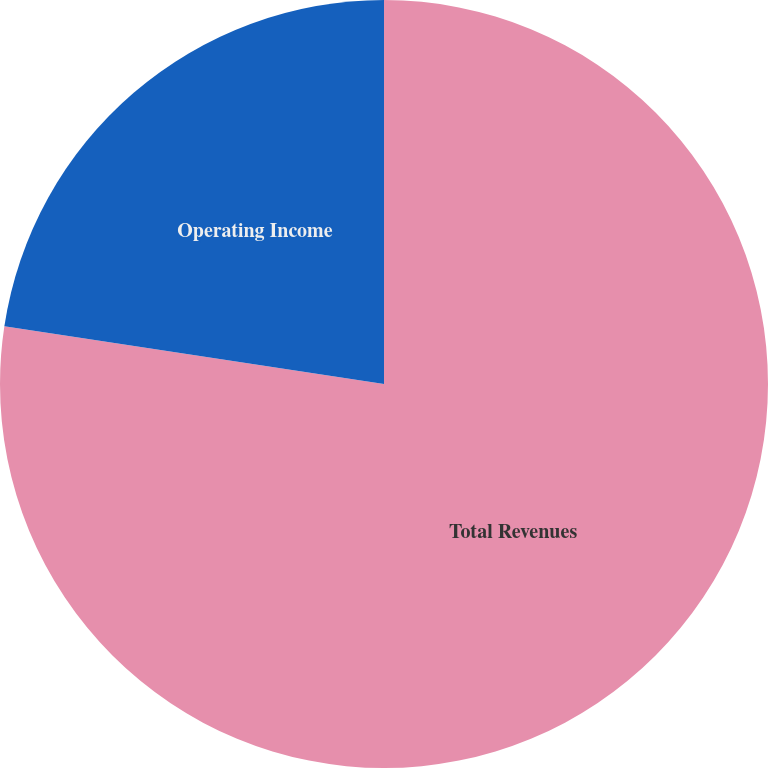Convert chart. <chart><loc_0><loc_0><loc_500><loc_500><pie_chart><fcel>Total Revenues<fcel>Operating Income<nl><fcel>77.4%<fcel>22.6%<nl></chart> 